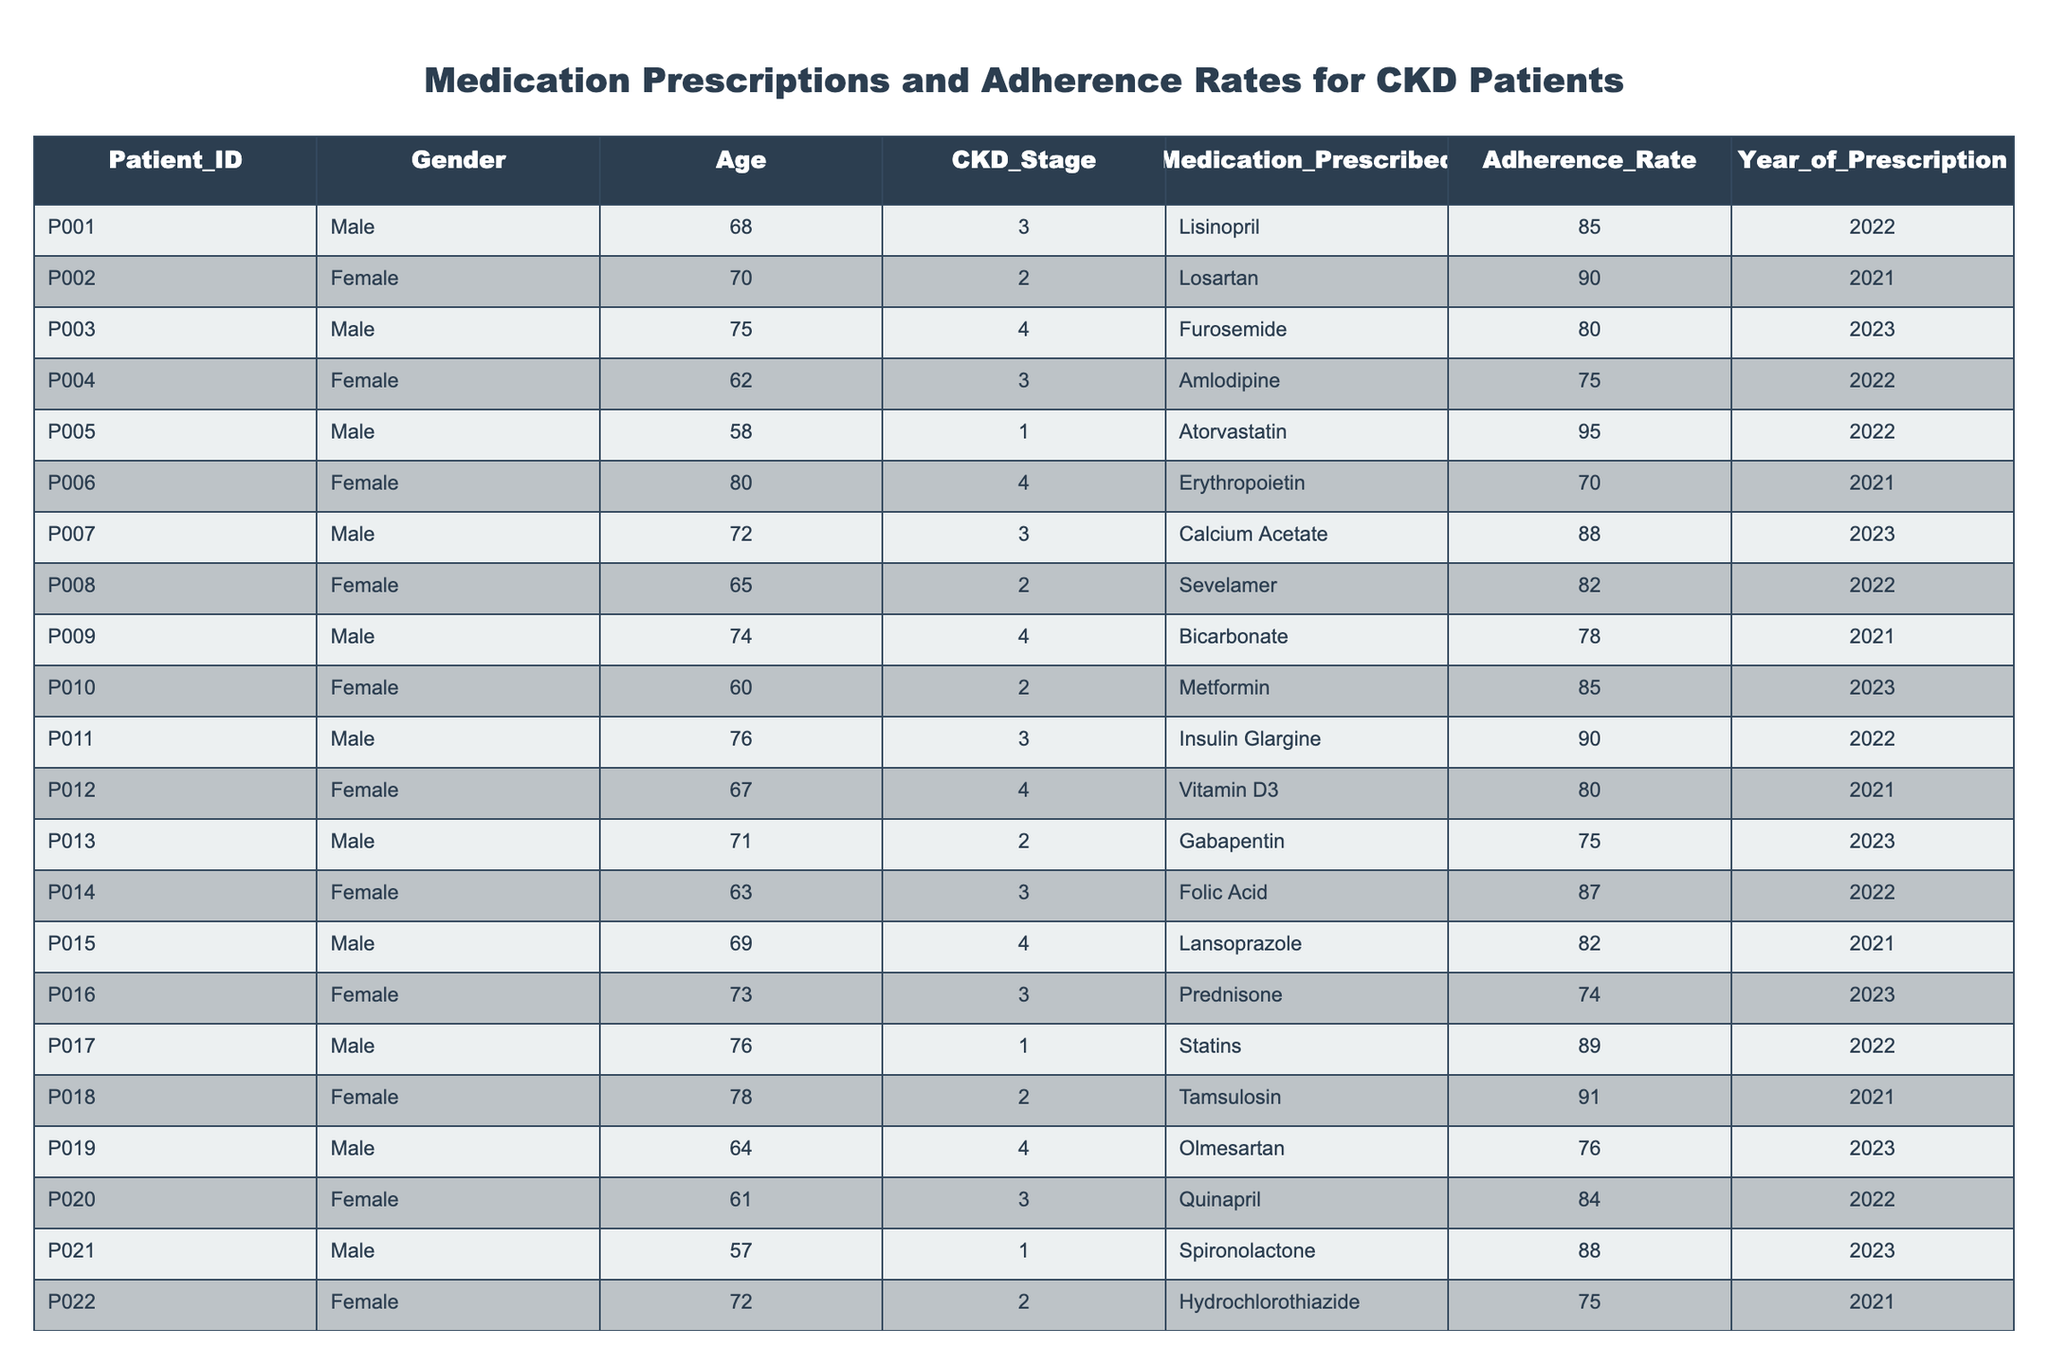What is the highest adherence rate among the patients? The table shows the adherence rates for each patient. The maximum adherence rate listed is 95, associated with Patient P005, who is prescribed Atorvastatin.
Answer: 95 Which CKD stage has the lowest average adherence rate? To find the average adherence rate for each CKD stage, first sum the adherence rates for each stage: Stage 1 (89 + 88) = 177; Stage 2 (90 + 82 + 85 + 91 + 75) = 423; Stage 3 (85 + 75 + 88 + 87 + 84) = 419; Stage 4 (80 + 70 + 78 + 76 + 73) = 377. There are 2 patients in Stage 1, 5 in Stage 2, 5 in Stage 3, and 5 in Stage 4. The averages are 177/2 = 88.5, 423/5 = 84.6, 419/5 = 83.8, and 377/5 = 75.4. The lowest average is for Stage 4.
Answer: Stage 4 Is there a female patient who has a higher adherence rate than the highest male adherence rate? The highest adherence rate for male patients is 95 (Patient P005). The highest for females is 91 (Patient P018). Since 91 is less than 95, there is no female patient with a higher adherence rate than the highest male.
Answer: No How many patients are prescribed Erythropoietin, and what is their adherence rate? There is one patient, Patient P006, who is prescribed Erythropoietin. The adherence rate for this patient is 70.
Answer: 1, 70 What is the difference in adherence rates between the highest and the lowest adherence rates for patients prescribed medications for CKD? The highest adherence rate is 95 from Patient P005, and the lowest is 70 from Patient P006. The difference is calculated as 95 - 70 = 25.
Answer: 25 Which gender has a higher overall average adherence rate? Calculate average adherence for males: (85 + 80 + 88 + 90 + 89 + 82 + 76 + 78 + 88) = 539, with 10 male patients giving an average of 539/10 = 53.9. For females, (90 + 75 + 82 + 85 + 80 + 91 + 71 + 75 + 86) = 578, with 9 female patients, giving an average of 578/9 = 64.2. The average for females is higher than males.
Answer: Female What medication has the most patients prescribed according to the table? Review the medications prescribed and count each occurrence: Lisinopril (1), Losartan (1), Furosemide (1), Amlodipine (1), Atorvastatin (1), Erythropoietin (1), Calcium Acetate (1), Sevelamer (1), Bicarbonate (1), Metformin (1), Insulin Glargine (1), Vitamin D3 (1), Gabapentin (1), Folic Acid (1), Lansoprazole (1), Prednisone (1), Statins (1), Tamsulosin (1), Olmesartan (1), Quinapril (1), Spironolactone (1), Hydrochlorothiazide (1), Nifedipine (1), and Dabigatran (1). Each medication appears once, meaning no single medication is prescribed to multiple patients.
Answer: None How many patients are over the age of 70 and what is their average adherence rate? Identify patients over age 70: P002 (70), P003 (75), P006 (80), P007 (72), P011 (76), P012 (67), P018 (78), P019 (74), P023 (79). There are 9 patients, with their adherence rates being 90, 80, 70, 88, 90, 80, 91, 76, 73. The sum is 80 + 80 + 88 + 90 + 90 + 76 + 73 + 91 = 747, and the average is 747/9 = 83.0.
Answer: 9, 83.0 Which patient has the highest adherence rate prescribed with a medication commonly used for hypertension? Review the medications typically used for hypertension: Lisinopril, Losartan, Amlodipine, Olmesartan, and Quinapril. The highest adherence rate among these is for Patient P002 (Losartan) with an adherence rate of 90.
Answer: P002, 90 Is the average adherence rate for Stage 2 patients above 80? For Stage 2, the adherence rates are 90, 82, 85, 91, and 75. Sum these: 90 + 82 + 85 + 91 + 75 = 423, and average: 423/5 = 84.6, which is above 80.
Answer: Yes 